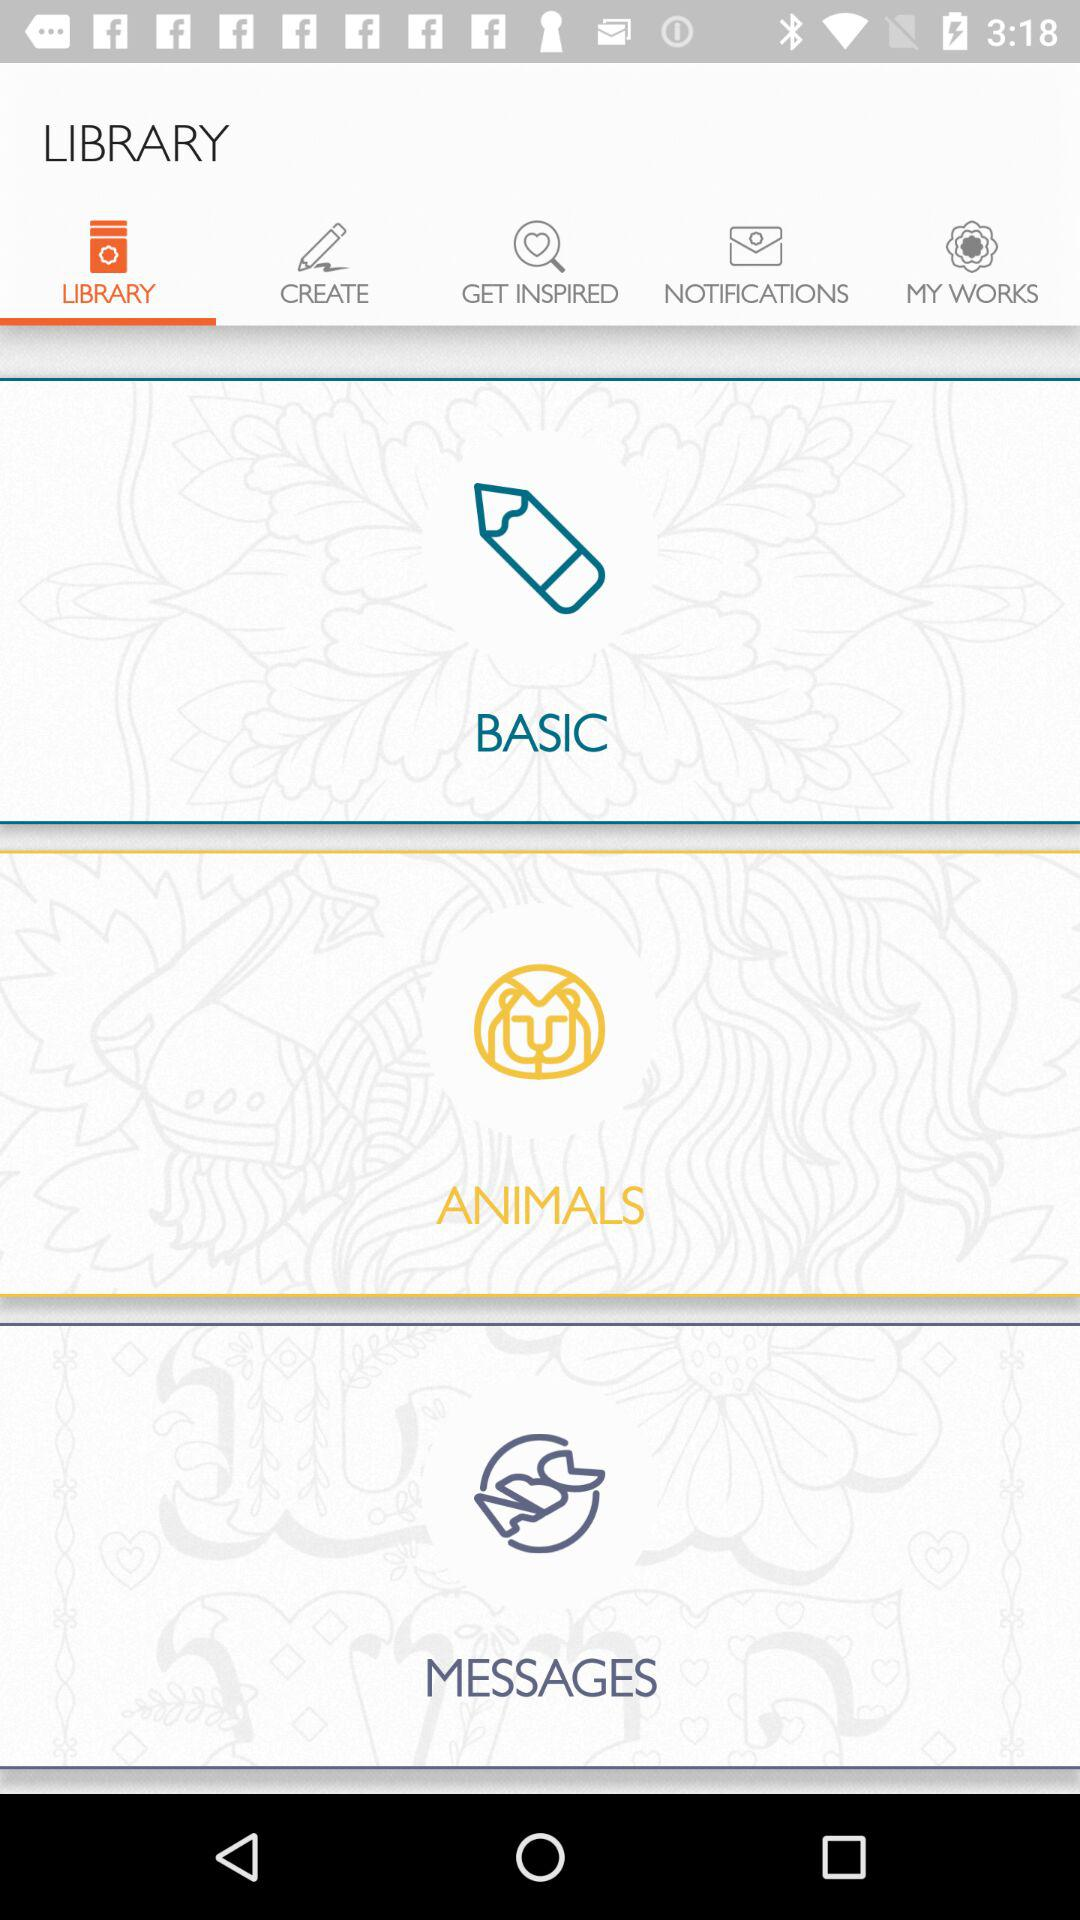Which tab is open? The tab is "LIBRARY". 